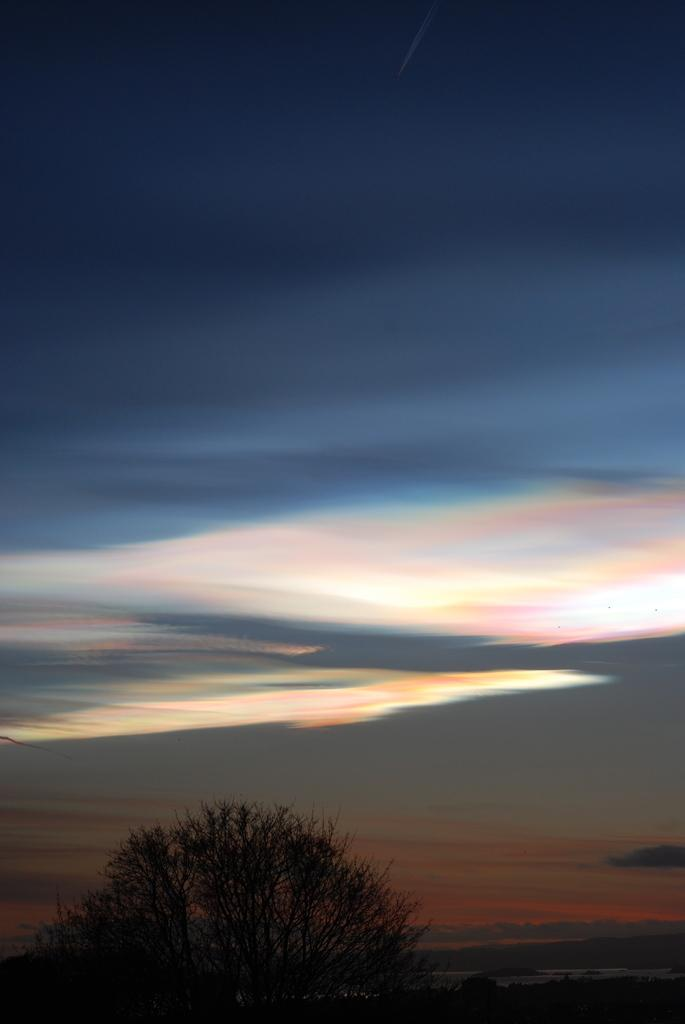What type of vegetation is present at the bottom of the image? There are trees at the bottom of the image. What part of the natural environment is visible at the top of the image? The sky is visible at the top of the image. What type of bulb is used to control the car in the image? There is no car or bulb present in the image; it only features trees and the sky. 